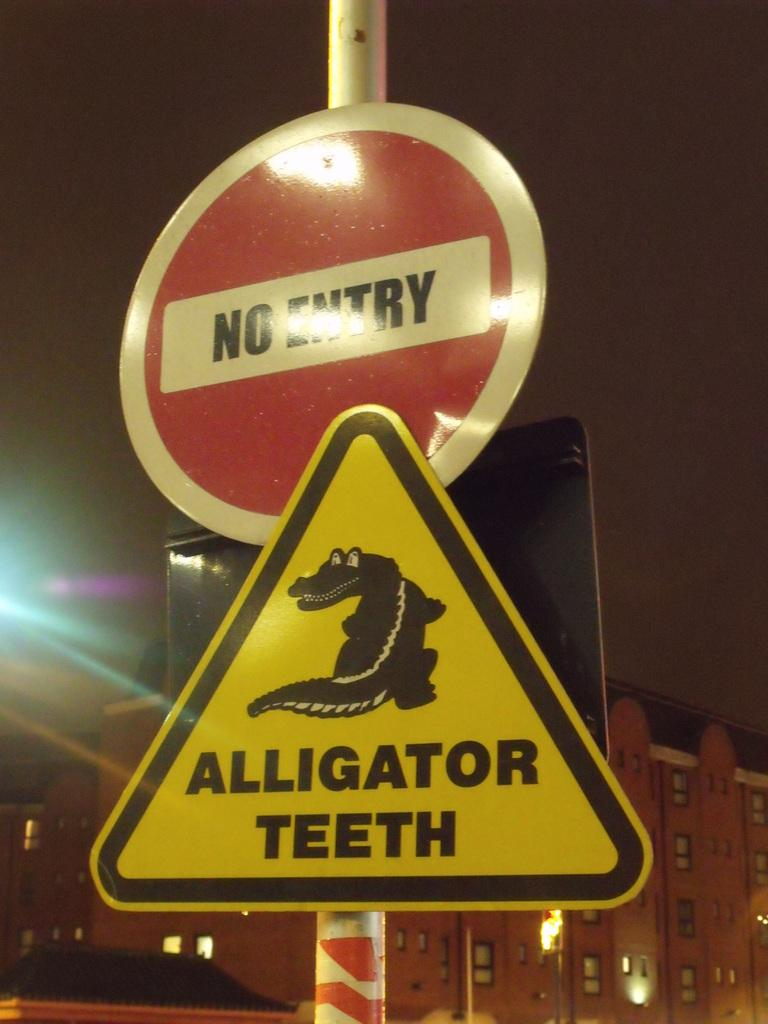<image>
Describe the image concisely. A red and white sign says No Entry and another sign beneath it says Alligator Teeth. 